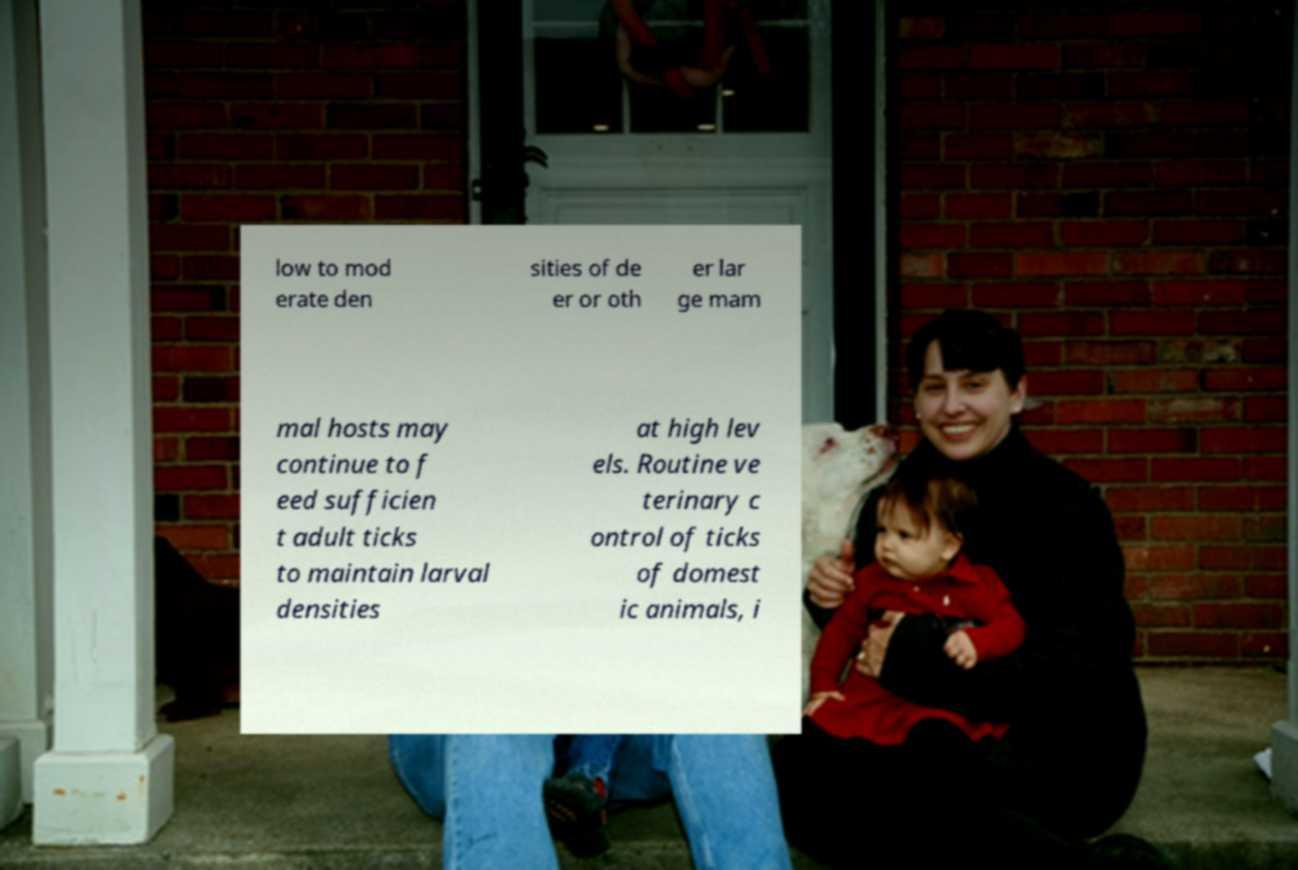Can you read and provide the text displayed in the image?This photo seems to have some interesting text. Can you extract and type it out for me? low to mod erate den sities of de er or oth er lar ge mam mal hosts may continue to f eed sufficien t adult ticks to maintain larval densities at high lev els. Routine ve terinary c ontrol of ticks of domest ic animals, i 